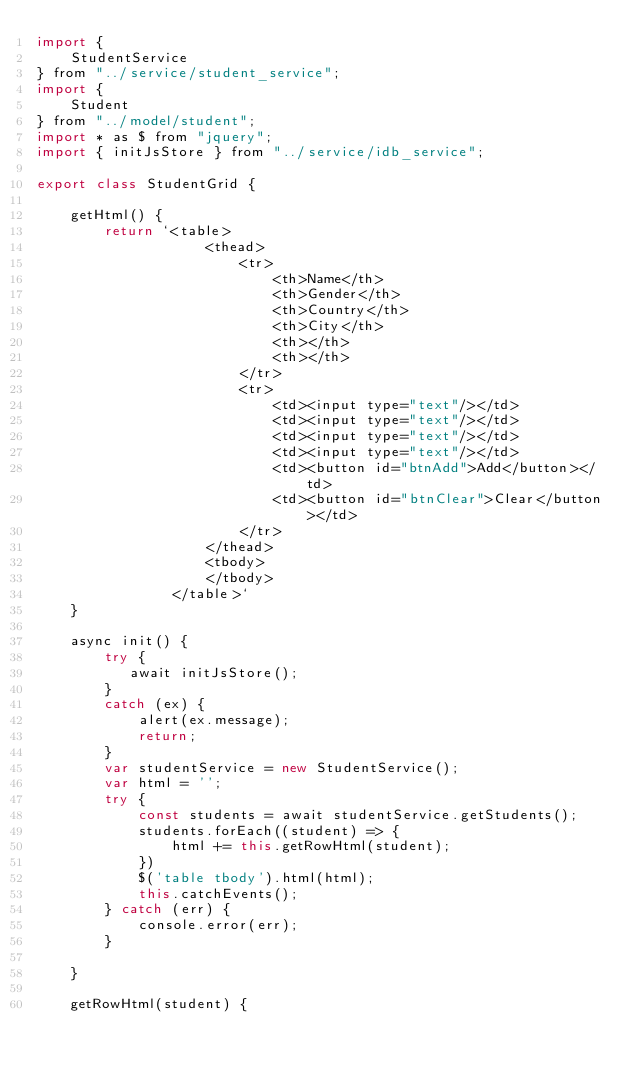Convert code to text. <code><loc_0><loc_0><loc_500><loc_500><_JavaScript_>import {
    StudentService
} from "../service/student_service";
import {
    Student
} from "../model/student";
import * as $ from "jquery";
import { initJsStore } from "../service/idb_service";

export class StudentGrid {

    getHtml() {
        return `<table>
                    <thead>
                        <tr>
                            <th>Name</th>
                            <th>Gender</th>
                            <th>Country</th>
                            <th>City</th>
                            <th></th>
                            <th></th>
                        </tr>
                        <tr>
                            <td><input type="text"/></td>
                            <td><input type="text"/></td>
                            <td><input type="text"/></td>
                            <td><input type="text"/></td>
                            <td><button id="btnAdd">Add</button></td>
                            <td><button id="btnClear">Clear</button></td>
                        </tr>
                    </thead>
                    <tbody>
                    </tbody>
                </table>`
    }

    async init() {
        try {
           await initJsStore();
        }
        catch (ex) {
            alert(ex.message);
            return;
        }
        var studentService = new StudentService();
        var html = '';
        try {
            const students = await studentService.getStudents();
            students.forEach((student) => {
                html += this.getRowHtml(student);
            })
            $('table tbody').html(html);
            this.catchEvents();
        } catch (err) {
            console.error(err);
        }

    }

    getRowHtml(student) {</code> 